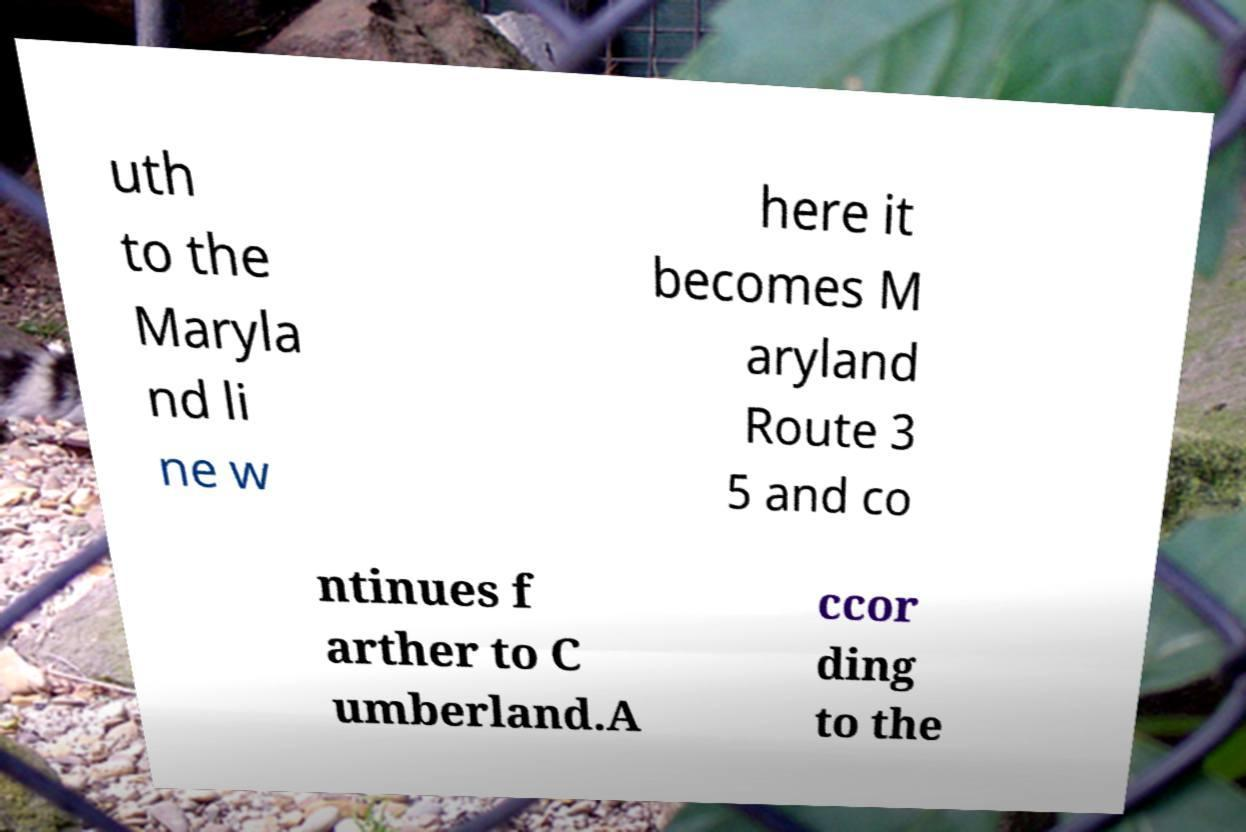Please read and relay the text visible in this image. What does it say? uth to the Maryla nd li ne w here it becomes M aryland Route 3 5 and co ntinues f arther to C umberland.A ccor ding to the 